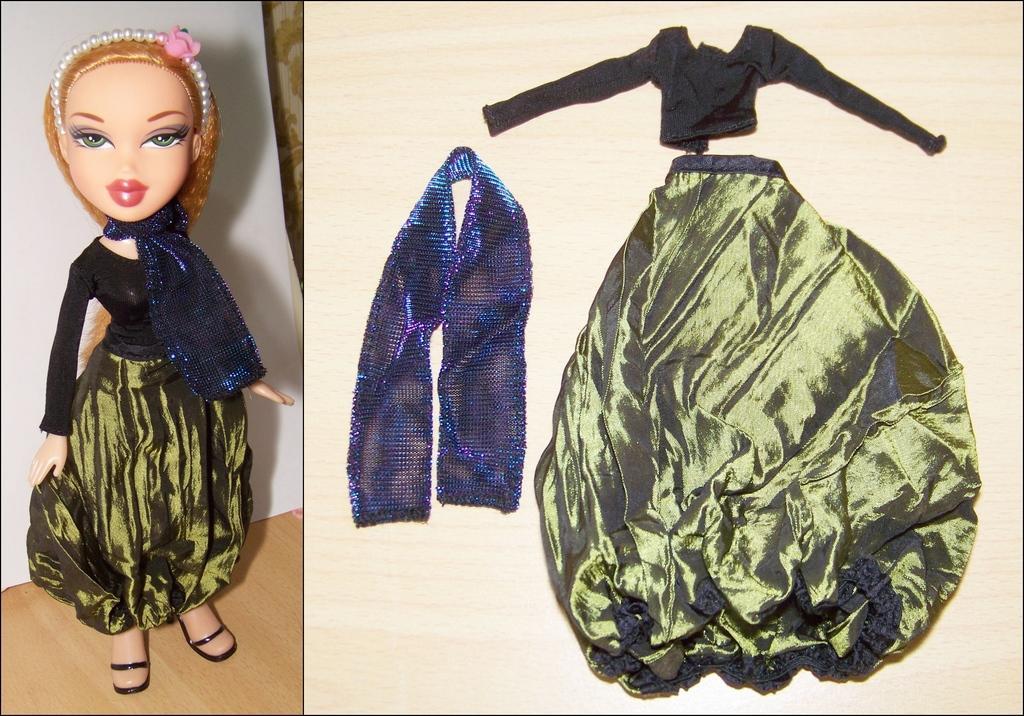Describe this image in one or two sentences. This picture is a collage of two images. In the first image I can observe a doll. I can observe black and green color dress on the doll. In the second image I can observe a dress placed on the cream color surface. 